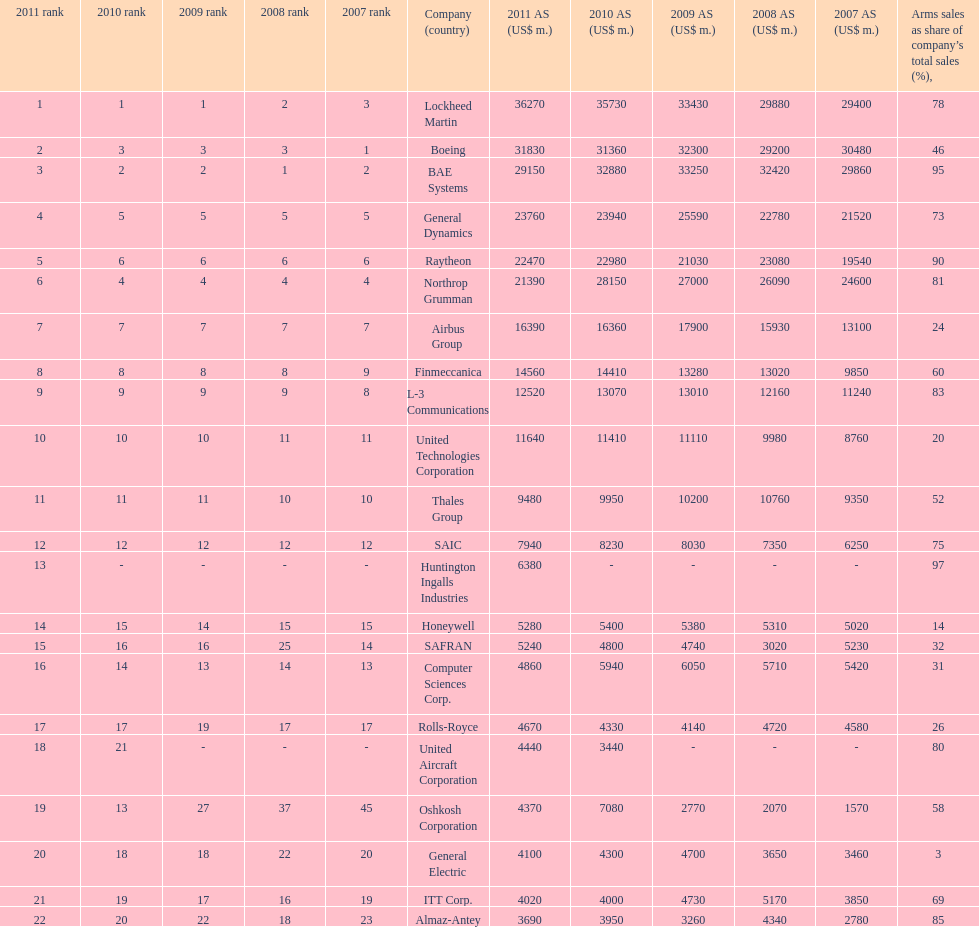Help me parse the entirety of this table. {'header': ['2011 rank', '2010 rank', '2009 rank', '2008 rank', '2007 rank', 'Company (country)', '2011 AS (US$ m.)', '2010 AS (US$ m.)', '2009 AS (US$ m.)', '2008 AS (US$ m.)', '2007 AS (US$ m.)', 'Arms sales as share of company’s total sales (%),'], 'rows': [['1', '1', '1', '2', '3', 'Lockheed Martin', '36270', '35730', '33430', '29880', '29400', '78'], ['2', '3', '3', '3', '1', 'Boeing', '31830', '31360', '32300', '29200', '30480', '46'], ['3', '2', '2', '1', '2', 'BAE Systems', '29150', '32880', '33250', '32420', '29860', '95'], ['4', '5', '5', '5', '5', 'General Dynamics', '23760', '23940', '25590', '22780', '21520', '73'], ['5', '6', '6', '6', '6', 'Raytheon', '22470', '22980', '21030', '23080', '19540', '90'], ['6', '4', '4', '4', '4', 'Northrop Grumman', '21390', '28150', '27000', '26090', '24600', '81'], ['7', '7', '7', '7', '7', 'Airbus Group', '16390', '16360', '17900', '15930', '13100', '24'], ['8', '8', '8', '8', '9', 'Finmeccanica', '14560', '14410', '13280', '13020', '9850', '60'], ['9', '9', '9', '9', '8', 'L-3 Communications', '12520', '13070', '13010', '12160', '11240', '83'], ['10', '10', '10', '11', '11', 'United Technologies Corporation', '11640', '11410', '11110', '9980', '8760', '20'], ['11', '11', '11', '10', '10', 'Thales Group', '9480', '9950', '10200', '10760', '9350', '52'], ['12', '12', '12', '12', '12', 'SAIC', '7940', '8230', '8030', '7350', '6250', '75'], ['13', '-', '-', '-', '-', 'Huntington Ingalls Industries', '6380', '-', '-', '-', '-', '97'], ['14', '15', '14', '15', '15', 'Honeywell', '5280', '5400', '5380', '5310', '5020', '14'], ['15', '16', '16', '25', '14', 'SAFRAN', '5240', '4800', '4740', '3020', '5230', '32'], ['16', '14', '13', '14', '13', 'Computer Sciences Corp.', '4860', '5940', '6050', '5710', '5420', '31'], ['17', '17', '19', '17', '17', 'Rolls-Royce', '4670', '4330', '4140', '4720', '4580', '26'], ['18', '21', '-', '-', '-', 'United Aircraft Corporation', '4440', '3440', '-', '-', '-', '80'], ['19', '13', '27', '37', '45', 'Oshkosh Corporation', '4370', '7080', '2770', '2070', '1570', '58'], ['20', '18', '18', '22', '20', 'General Electric', '4100', '4300', '4700', '3650', '3460', '3'], ['21', '19', '17', '16', '19', 'ITT Corp.', '4020', '4000', '4730', '5170', '3850', '69'], ['22', '20', '22', '18', '23', 'Almaz-Antey', '3690', '3950', '3260', '4340', '2780', '85']]} What country is the first listed country? USA. 